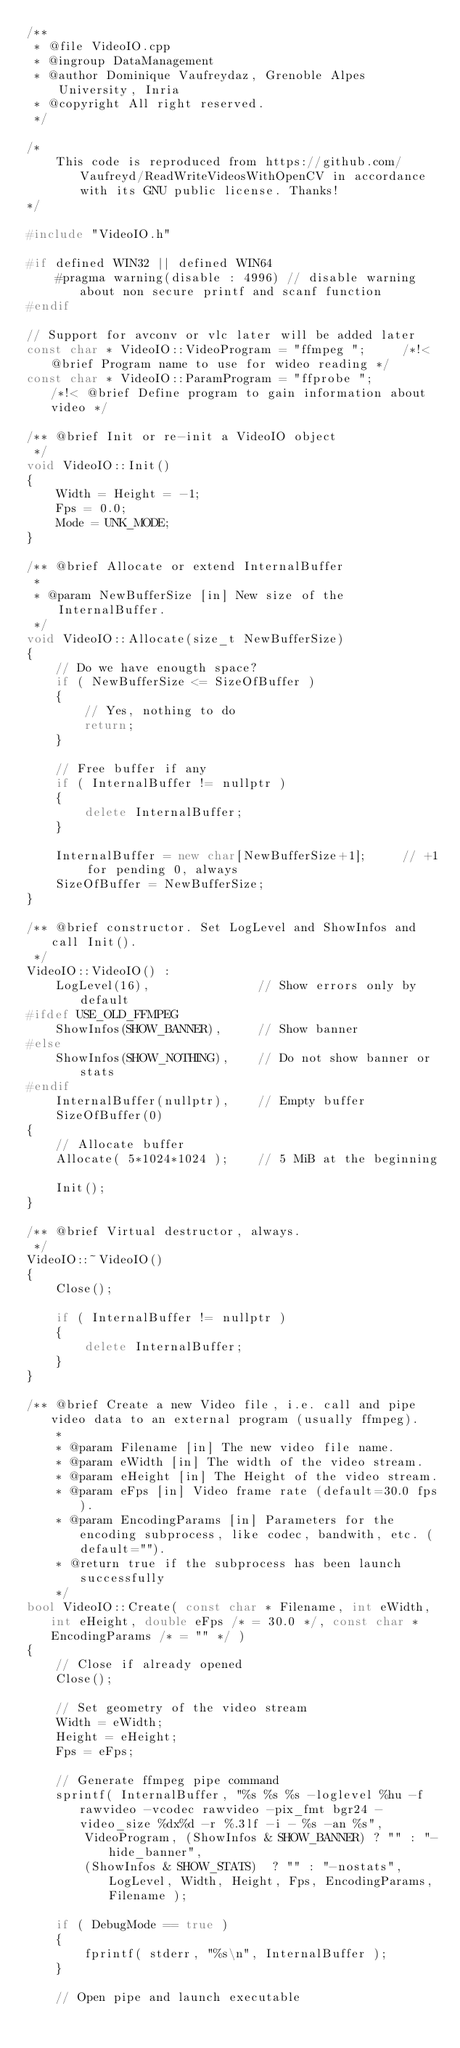<code> <loc_0><loc_0><loc_500><loc_500><_C++_>/**
 * @file VideoIO.cpp
 * @ingroup DataManagement
 * @author Dominique Vaufreydaz, Grenoble Alpes University, Inria
 * @copyright All right reserved.
 */

/* 
	This code is reproduced from https://github.com/Vaufreyd/ReadWriteVideosWithOpenCV in accordance with its GNU public license. Thanks!
*/

#include "VideoIO.h"

#if defined WIN32 || defined WIN64
	#pragma warning(disable : 4996) // disable warning about non secure printf and scanf function
#endif

// Support for avconv or vlc later will be added later
const char * VideoIO::VideoProgram = "ffmpeg ";		/*!< @brief Program name to use for wideo reading */
const char * VideoIO::ParamProgram = "ffprobe ";		/*!< @brief Define program to gain information about video */

/** @brief Init or re-init a VideoIO object
 */
void VideoIO::Init()
{
	Width = Height = -1;
	Fps = 0.0;
	Mode = UNK_MODE;
}

/** @brief Allocate or extend InternalBuffer
 *
 * @param NewBufferSize [in] New size of the InternalBuffer.
 */
void VideoIO::Allocate(size_t NewBufferSize)
{
	// Do we have enougth space?
	if ( NewBufferSize <= SizeOfBuffer )
	{
		// Yes, nothing to do
		return;
	}

	// Free buffer if any
	if ( InternalBuffer != nullptr )
	{
		delete InternalBuffer;
	}

	InternalBuffer = new char[NewBufferSize+1];		// +1 for pending 0, always
	SizeOfBuffer = NewBufferSize;
}

/** @brief constructor. Set LogLevel and ShowInfos and call Init().
 */
VideoIO::VideoIO() :
	LogLevel(16),				// Show errors only by default
#ifdef USE_OLD_FFMPEG
	ShowInfos(SHOW_BANNER),		// Show banner
#else
	ShowInfos(SHOW_NOTHING),	// Do not show banner or stats
#endif
	InternalBuffer(nullptr),	// Empty buffer
	SizeOfBuffer(0)
{
	// Allocate buffer
	Allocate( 5*1024*1024 );	// 5 MiB at the beginning

	Init();
}

/** @brief Virtual destructor, always.
 */
VideoIO::~VideoIO()
{
	Close();

	if ( InternalBuffer != nullptr )
	{
		delete InternalBuffer;
	}
}

/** @brief Create a new Video file, i.e. call and pipe video data to an external program (usually ffmpeg).
	*
	* @param Filename [in] The new video file name.
	* @param eWidth [in] The width of the video stream.
	* @param eHeight [in] The Height of the video stream.
	* @param eFps [in] Video frame rate (default=30.0 fps).
	* @param EncodingParams [in] Parameters for the encoding subprocess, like codec, bandwith, etc. (default="").
	* @return true if the subprocess has been launch successfully
	*/
bool VideoIO::Create( const char * Filename, int eWidth, int eHeight, double eFps /* = 30.0 */, const char * EncodingParams /* = "" */ )
{
	// Close if already opened
	Close();

	// Set geometry of the video stream
	Width = eWidth;
	Height = eHeight;
	Fps = eFps;

	// Generate ffmpeg pipe command
	sprintf( InternalBuffer, "%s %s %s -loglevel %hu -f rawvideo -vcodec rawvideo -pix_fmt bgr24 -video_size %dx%d -r %.3lf -i - %s -an %s",
		VideoProgram, (ShowInfos & SHOW_BANNER) ? "" : "-hide_banner", 
		(ShowInfos & SHOW_STATS)  ? "" : "-nostats", LogLevel, Width, Height, Fps, EncodingParams, Filename );

	if ( DebugMode == true )
	{
		fprintf( stderr, "%s\n", InternalBuffer );
	}
		
	// Open pipe and launch executable</code> 